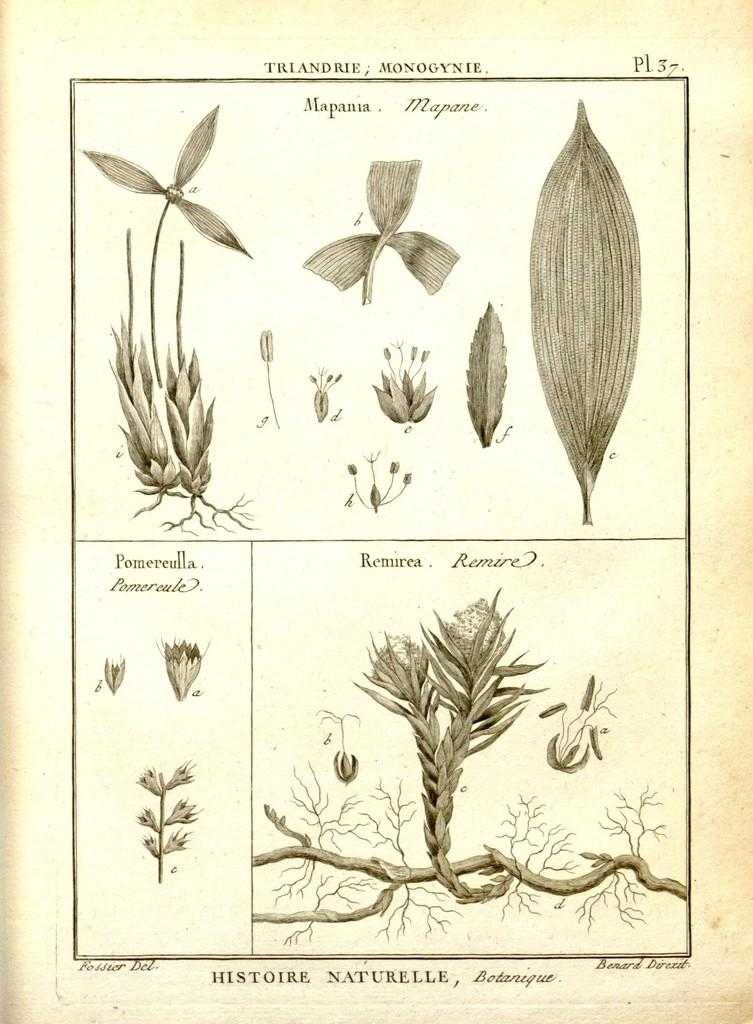What is the color scheme of the image? The image is black and white. What types of living organisms can be seen in the image? There are different plants in the image. Is there any text present in the image? Yes, there is text in the image. What type of prose can be seen in the image? There is no prose present in the image; it contains only plants and text. How many cents are visible in the image? There are no cents present in the image. 